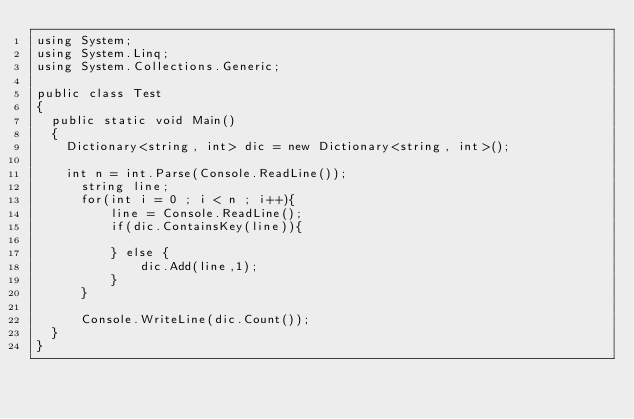<code> <loc_0><loc_0><loc_500><loc_500><_C#_>using System;
using System.Linq;
using System.Collections.Generic;

public class Test
{
	public static void Main()
	{
		Dictionary<string, int> dic = new Dictionary<string, int>();

		int n = int.Parse(Console.ReadLine());
	    string line;
	    for(int i = 0 ; i < n ; i++){
	        line = Console.ReadLine();
	        if(dic.ContainsKey(line)){
	            
	        } else {
	            dic.Add(line,1);
	        }
	    }
	    
	    Console.WriteLine(dic.Count());
	}                                                                                                                                                                       
}</code> 